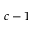Convert formula to latex. <formula><loc_0><loc_0><loc_500><loc_500>c - 1</formula> 